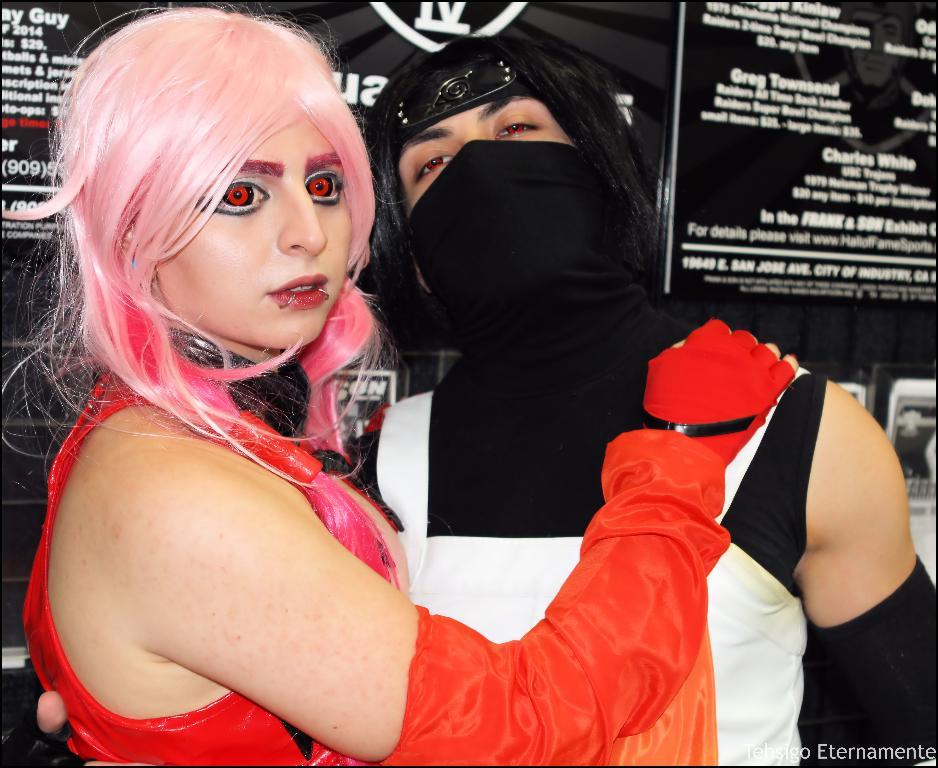<image>
Present a compact description of the photo's key features. a couple standing in front of a wall that says 'charles white' on it 